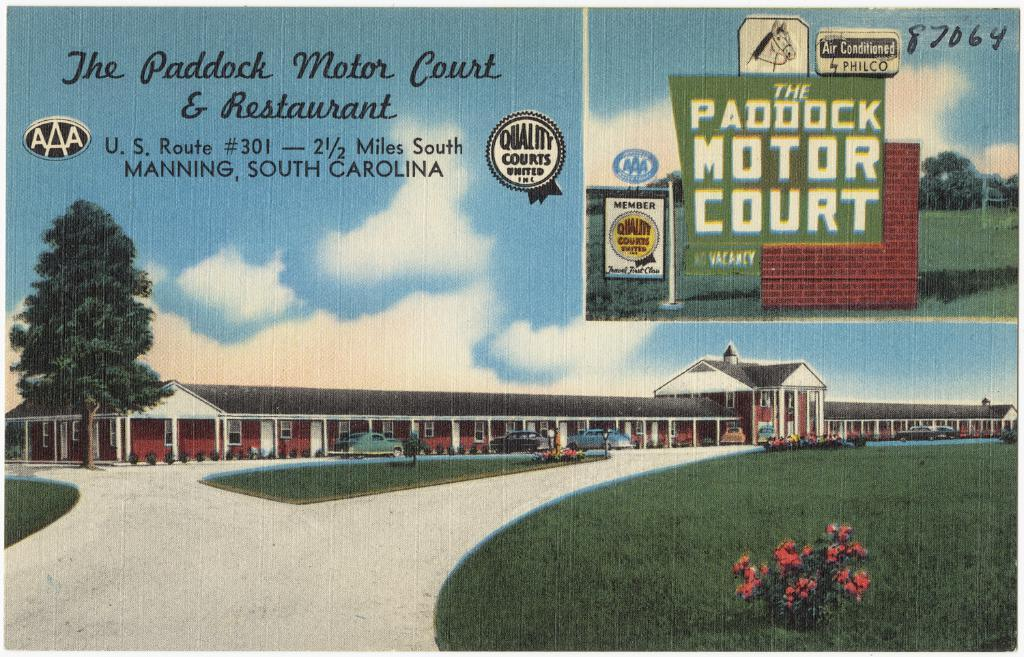<image>
Write a terse but informative summary of the picture. A vintage looking advertisement promotes The Paddock Motor Court & Restaurant. 